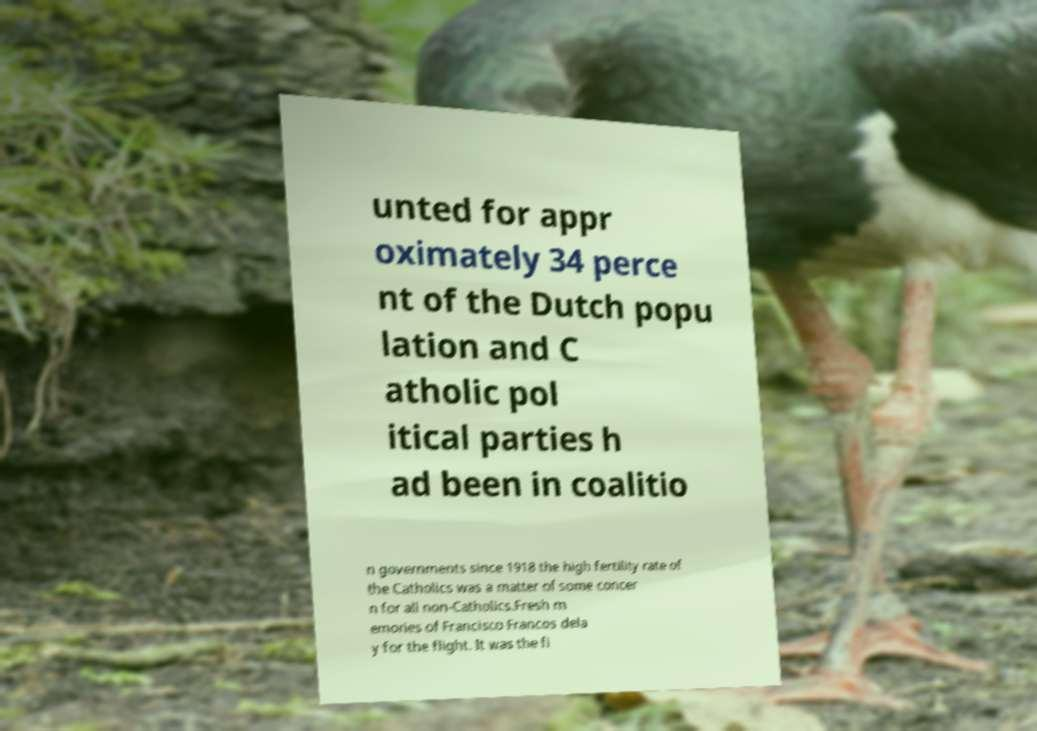Can you accurately transcribe the text from the provided image for me? unted for appr oximately 34 perce nt of the Dutch popu lation and C atholic pol itical parties h ad been in coalitio n governments since 1918 the high fertility rate of the Catholics was a matter of some concer n for all non-Catholics.Fresh m emories of Francisco Francos dela y for the flight. It was the fi 